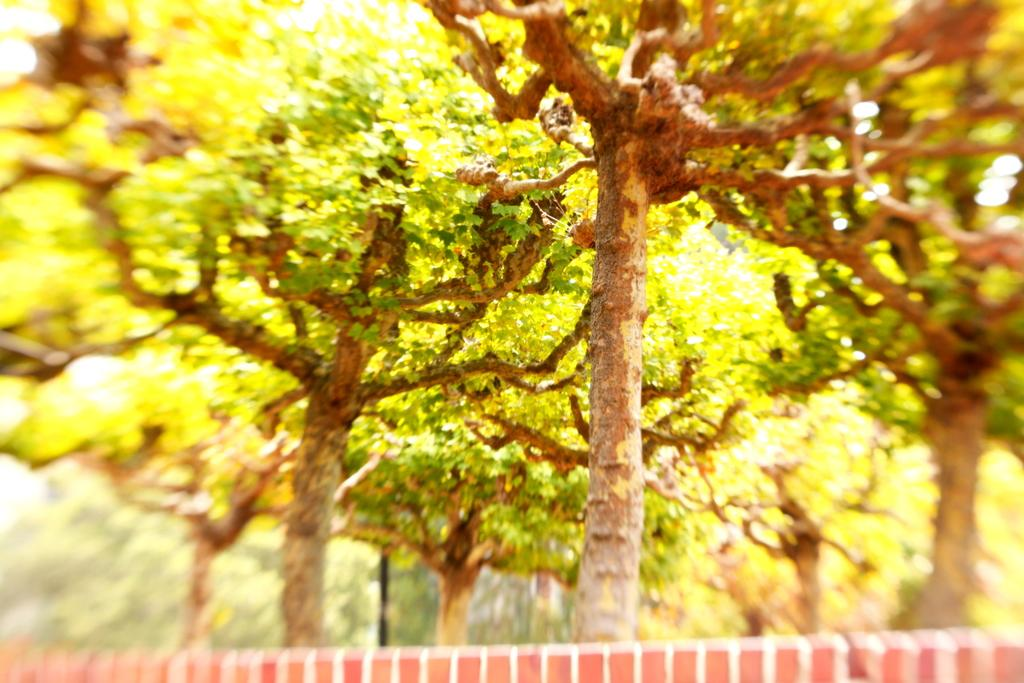What type of trees can be seen in the image? The facts provided do not specify the type of trees in the image. However, we can see that there are trees present. Can you see a tent among the trees in the image? There is no mention of a tent in the image, only trees. 